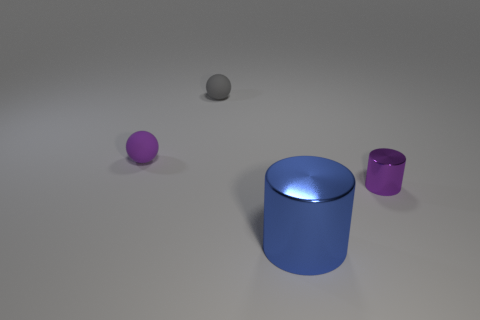What number of spheres are the same size as the blue cylinder?
Provide a succinct answer. 0. There is a purple thing that is on the left side of the purple metallic cylinder; is its size the same as the gray matte object that is to the left of the blue metallic object?
Offer a terse response. Yes. Are there more tiny purple things that are in front of the small purple rubber object than small purple metal cylinders that are behind the gray matte object?
Your response must be concise. Yes. What number of other purple rubber objects are the same shape as the small purple rubber object?
Offer a very short reply. 0. There is a cylinder that is the same size as the gray matte object; what is its material?
Ensure brevity in your answer.  Metal. Are there any small objects made of the same material as the gray sphere?
Provide a short and direct response. Yes. Is the number of gray rubber spheres in front of the blue shiny cylinder less than the number of tiny cyan metallic balls?
Your answer should be compact. No. There is a small thing on the right side of the cylinder that is in front of the purple shiny cylinder; what is its material?
Give a very brief answer. Metal. There is a thing that is in front of the tiny purple sphere and behind the big thing; what shape is it?
Your response must be concise. Cylinder. How many other objects are there of the same color as the big thing?
Offer a terse response. 0. 